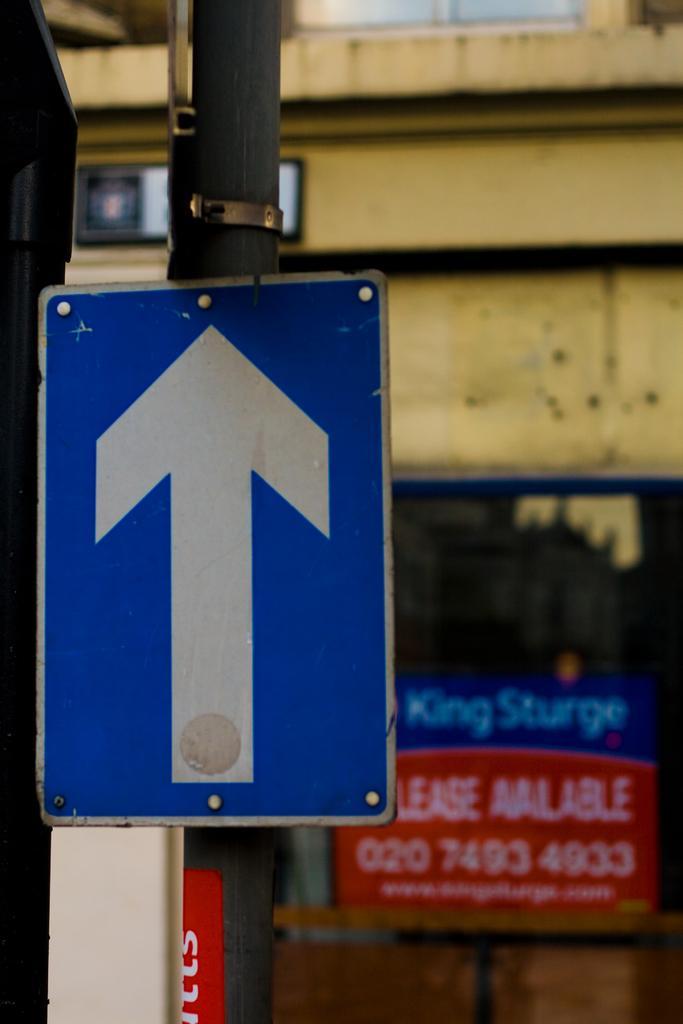In one or two sentences, can you explain what this image depicts? In the foreground of this picture, there is a sign board to a pole. In the background, there is a wall, glass and a board. 